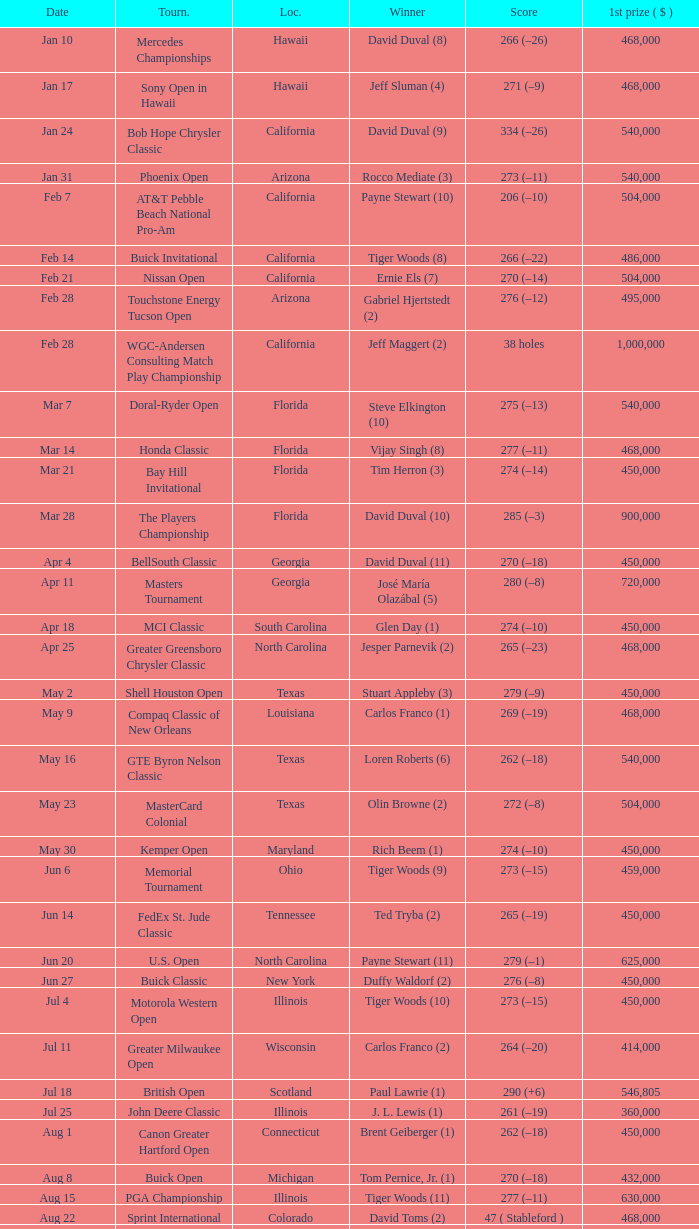What is the score of the B.C. Open in New York? 273 (–15). Could you help me parse every detail presented in this table? {'header': ['Date', 'Tourn.', 'Loc.', 'Winner', 'Score', '1st prize ( $ )'], 'rows': [['Jan 10', 'Mercedes Championships', 'Hawaii', 'David Duval (8)', '266 (–26)', '468,000'], ['Jan 17', 'Sony Open in Hawaii', 'Hawaii', 'Jeff Sluman (4)', '271 (–9)', '468,000'], ['Jan 24', 'Bob Hope Chrysler Classic', 'California', 'David Duval (9)', '334 (–26)', '540,000'], ['Jan 31', 'Phoenix Open', 'Arizona', 'Rocco Mediate (3)', '273 (–11)', '540,000'], ['Feb 7', 'AT&T Pebble Beach National Pro-Am', 'California', 'Payne Stewart (10)', '206 (–10)', '504,000'], ['Feb 14', 'Buick Invitational', 'California', 'Tiger Woods (8)', '266 (–22)', '486,000'], ['Feb 21', 'Nissan Open', 'California', 'Ernie Els (7)', '270 (–14)', '504,000'], ['Feb 28', 'Touchstone Energy Tucson Open', 'Arizona', 'Gabriel Hjertstedt (2)', '276 (–12)', '495,000'], ['Feb 28', 'WGC-Andersen Consulting Match Play Championship', 'California', 'Jeff Maggert (2)', '38 holes', '1,000,000'], ['Mar 7', 'Doral-Ryder Open', 'Florida', 'Steve Elkington (10)', '275 (–13)', '540,000'], ['Mar 14', 'Honda Classic', 'Florida', 'Vijay Singh (8)', '277 (–11)', '468,000'], ['Mar 21', 'Bay Hill Invitational', 'Florida', 'Tim Herron (3)', '274 (–14)', '450,000'], ['Mar 28', 'The Players Championship', 'Florida', 'David Duval (10)', '285 (–3)', '900,000'], ['Apr 4', 'BellSouth Classic', 'Georgia', 'David Duval (11)', '270 (–18)', '450,000'], ['Apr 11', 'Masters Tournament', 'Georgia', 'José María Olazábal (5)', '280 (–8)', '720,000'], ['Apr 18', 'MCI Classic', 'South Carolina', 'Glen Day (1)', '274 (–10)', '450,000'], ['Apr 25', 'Greater Greensboro Chrysler Classic', 'North Carolina', 'Jesper Parnevik (2)', '265 (–23)', '468,000'], ['May 2', 'Shell Houston Open', 'Texas', 'Stuart Appleby (3)', '279 (–9)', '450,000'], ['May 9', 'Compaq Classic of New Orleans', 'Louisiana', 'Carlos Franco (1)', '269 (–19)', '468,000'], ['May 16', 'GTE Byron Nelson Classic', 'Texas', 'Loren Roberts (6)', '262 (–18)', '540,000'], ['May 23', 'MasterCard Colonial', 'Texas', 'Olin Browne (2)', '272 (–8)', '504,000'], ['May 30', 'Kemper Open', 'Maryland', 'Rich Beem (1)', '274 (–10)', '450,000'], ['Jun 6', 'Memorial Tournament', 'Ohio', 'Tiger Woods (9)', '273 (–15)', '459,000'], ['Jun 14', 'FedEx St. Jude Classic', 'Tennessee', 'Ted Tryba (2)', '265 (–19)', '450,000'], ['Jun 20', 'U.S. Open', 'North Carolina', 'Payne Stewart (11)', '279 (–1)', '625,000'], ['Jun 27', 'Buick Classic', 'New York', 'Duffy Waldorf (2)', '276 (–8)', '450,000'], ['Jul 4', 'Motorola Western Open', 'Illinois', 'Tiger Woods (10)', '273 (–15)', '450,000'], ['Jul 11', 'Greater Milwaukee Open', 'Wisconsin', 'Carlos Franco (2)', '264 (–20)', '414,000'], ['Jul 18', 'British Open', 'Scotland', 'Paul Lawrie (1)', '290 (+6)', '546,805'], ['Jul 25', 'John Deere Classic', 'Illinois', 'J. L. Lewis (1)', '261 (–19)', '360,000'], ['Aug 1', 'Canon Greater Hartford Open', 'Connecticut', 'Brent Geiberger (1)', '262 (–18)', '450,000'], ['Aug 8', 'Buick Open', 'Michigan', 'Tom Pernice, Jr. (1)', '270 (–18)', '432,000'], ['Aug 15', 'PGA Championship', 'Illinois', 'Tiger Woods (11)', '277 (–11)', '630,000'], ['Aug 22', 'Sprint International', 'Colorado', 'David Toms (2)', '47 ( Stableford )', '468,000'], ['Aug 29', 'Reno-Tahoe Open', 'Nevada', 'Notah Begay III (1)', '274 (–14)', '495,000'], ['Aug 29', 'WGC-NEC Invitational', 'Ohio', 'Tiger Woods (12)', '270 (–10)', '1,000,000'], ['Sep 5', 'Air Canada Championship', 'Canada', 'Mike Weir (1)', '266 (–18)', '450,000'], ['Sep 12', 'Bell Canadian Open', 'Canada', 'Hal Sutton (11)', '275 (–13)', '450,000'], ['Sep 19', 'B.C. Open', 'New York', 'Brad Faxon (5)', '273 (–15)', '288,000'], ['Sep 26', 'Westin Texas Open', 'Texas', 'Duffy Waldorf (3)', '270 (–18)', '360,000'], ['Oct 3', 'Buick Challenge', 'Georgia', 'David Toms (3)', '271 (–17)', '324,000'], ['Oct 10', 'Michelob Championship at Kingsmill', 'Virginia', 'Notah Begay III (2)', '274 (–10)', '450,000'], ['Oct 17', 'Las Vegas Invitational', 'Nevada', 'Jim Furyk (4)', '331 (–29)', '450,000'], ['Oct 24', 'National Car Rental Golf Classic Disney', 'Florida', 'Tiger Woods (13)', '271 (–17)', '450,000'], ['Oct 31', 'The Tour Championship', 'Texas', 'Tiger Woods (14)', '269 (–15)', '900,000'], ['Nov 1', 'Southern Farm Bureau Classic', 'Mississippi', 'Brian Henninger (2)', '202 (–14)', '360,000'], ['Nov 7', 'WGC-American Express Championship', 'Spain', 'Tiger Woods (15)', '278 (–6)', '1,000,000']]} 